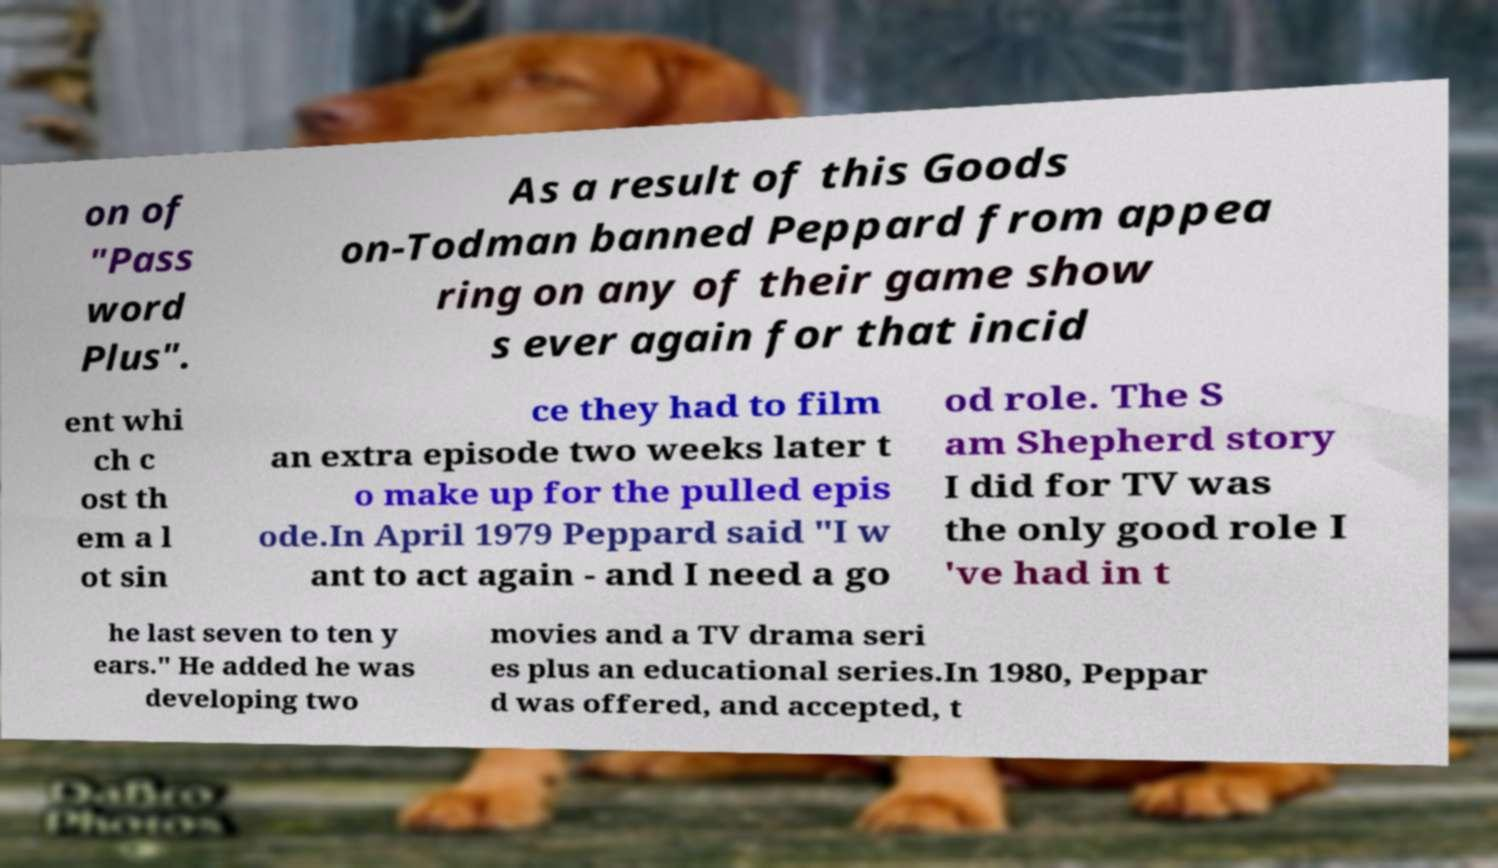Could you extract and type out the text from this image? on of "Pass word Plus". As a result of this Goods on-Todman banned Peppard from appea ring on any of their game show s ever again for that incid ent whi ch c ost th em a l ot sin ce they had to film an extra episode two weeks later t o make up for the pulled epis ode.In April 1979 Peppard said "I w ant to act again - and I need a go od role. The S am Shepherd story I did for TV was the only good role I 've had in t he last seven to ten y ears." He added he was developing two movies and a TV drama seri es plus an educational series.In 1980, Peppar d was offered, and accepted, t 